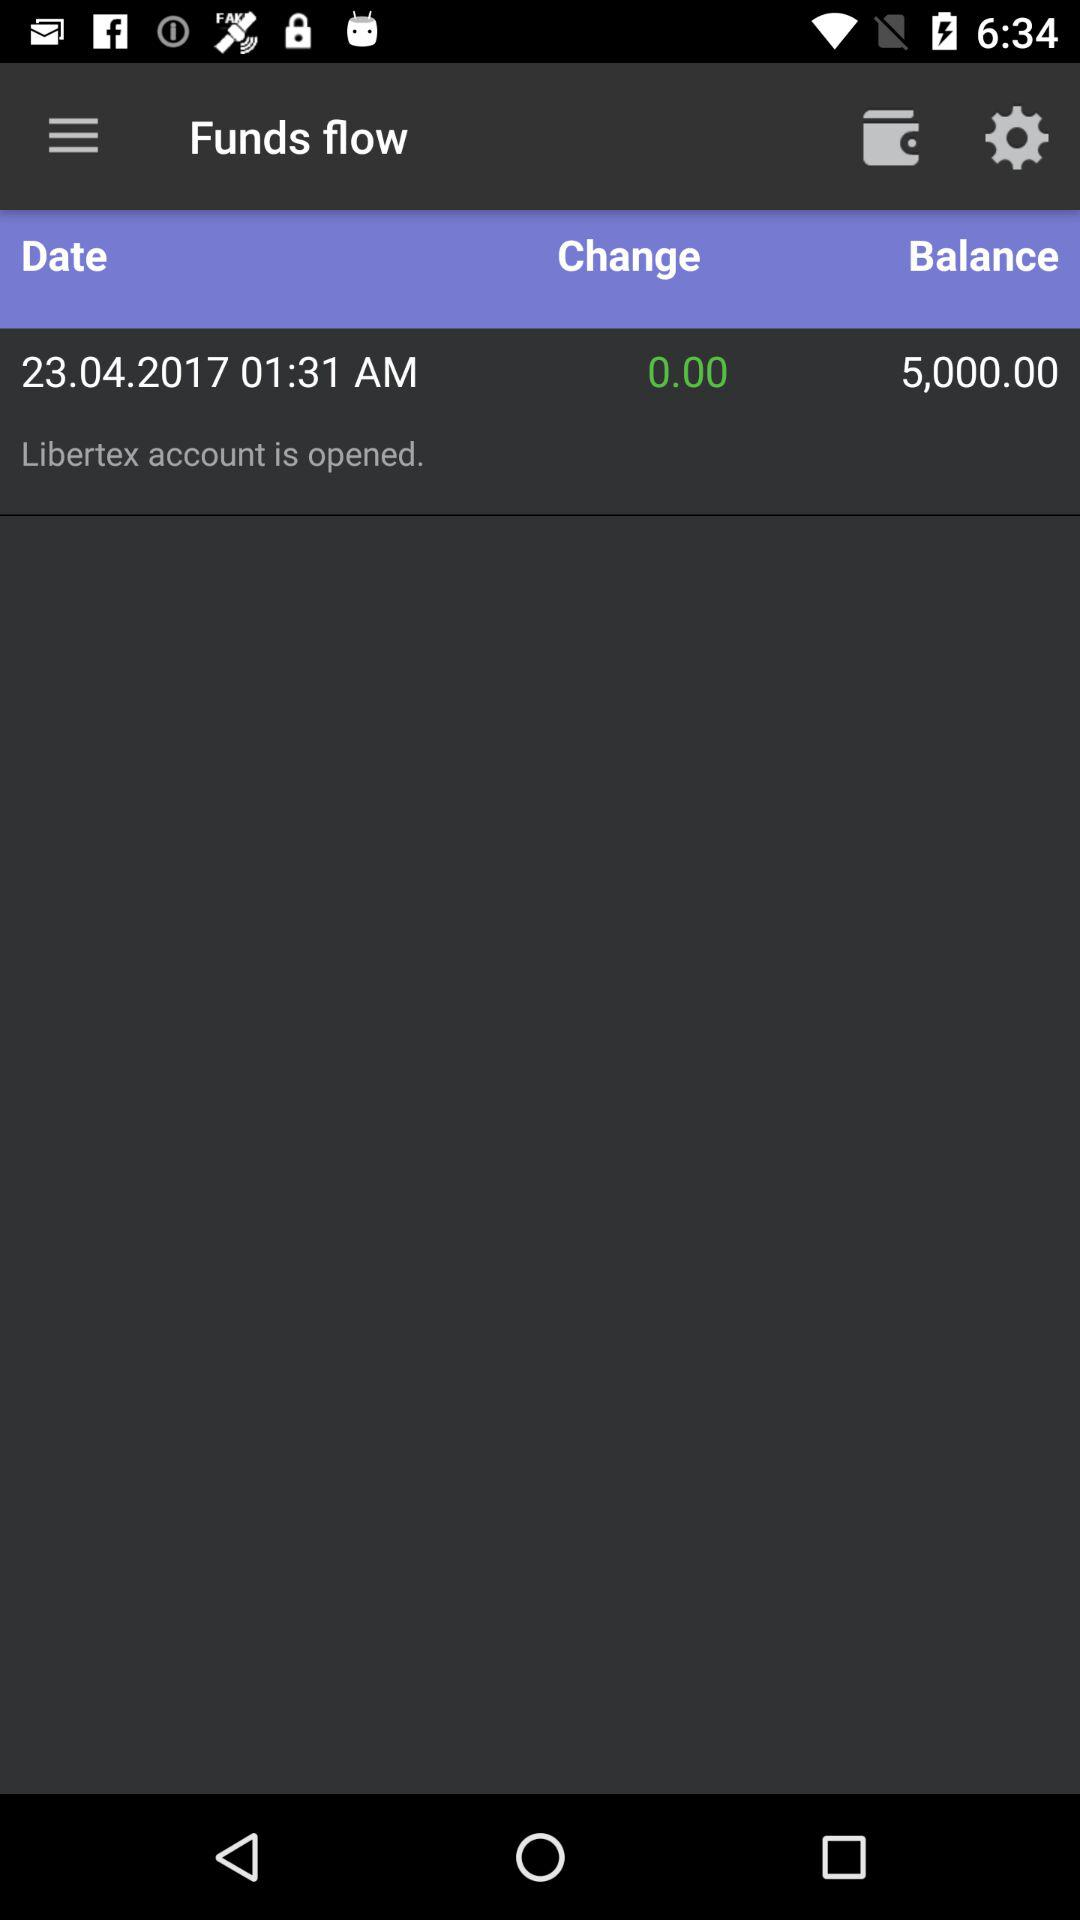What is the mentioned date? The mentioned date is April 23, 2017. 